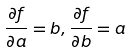Convert formula to latex. <formula><loc_0><loc_0><loc_500><loc_500>\frac { \partial f } { \partial a } = b , \frac { \partial f } { \partial b } = a</formula> 